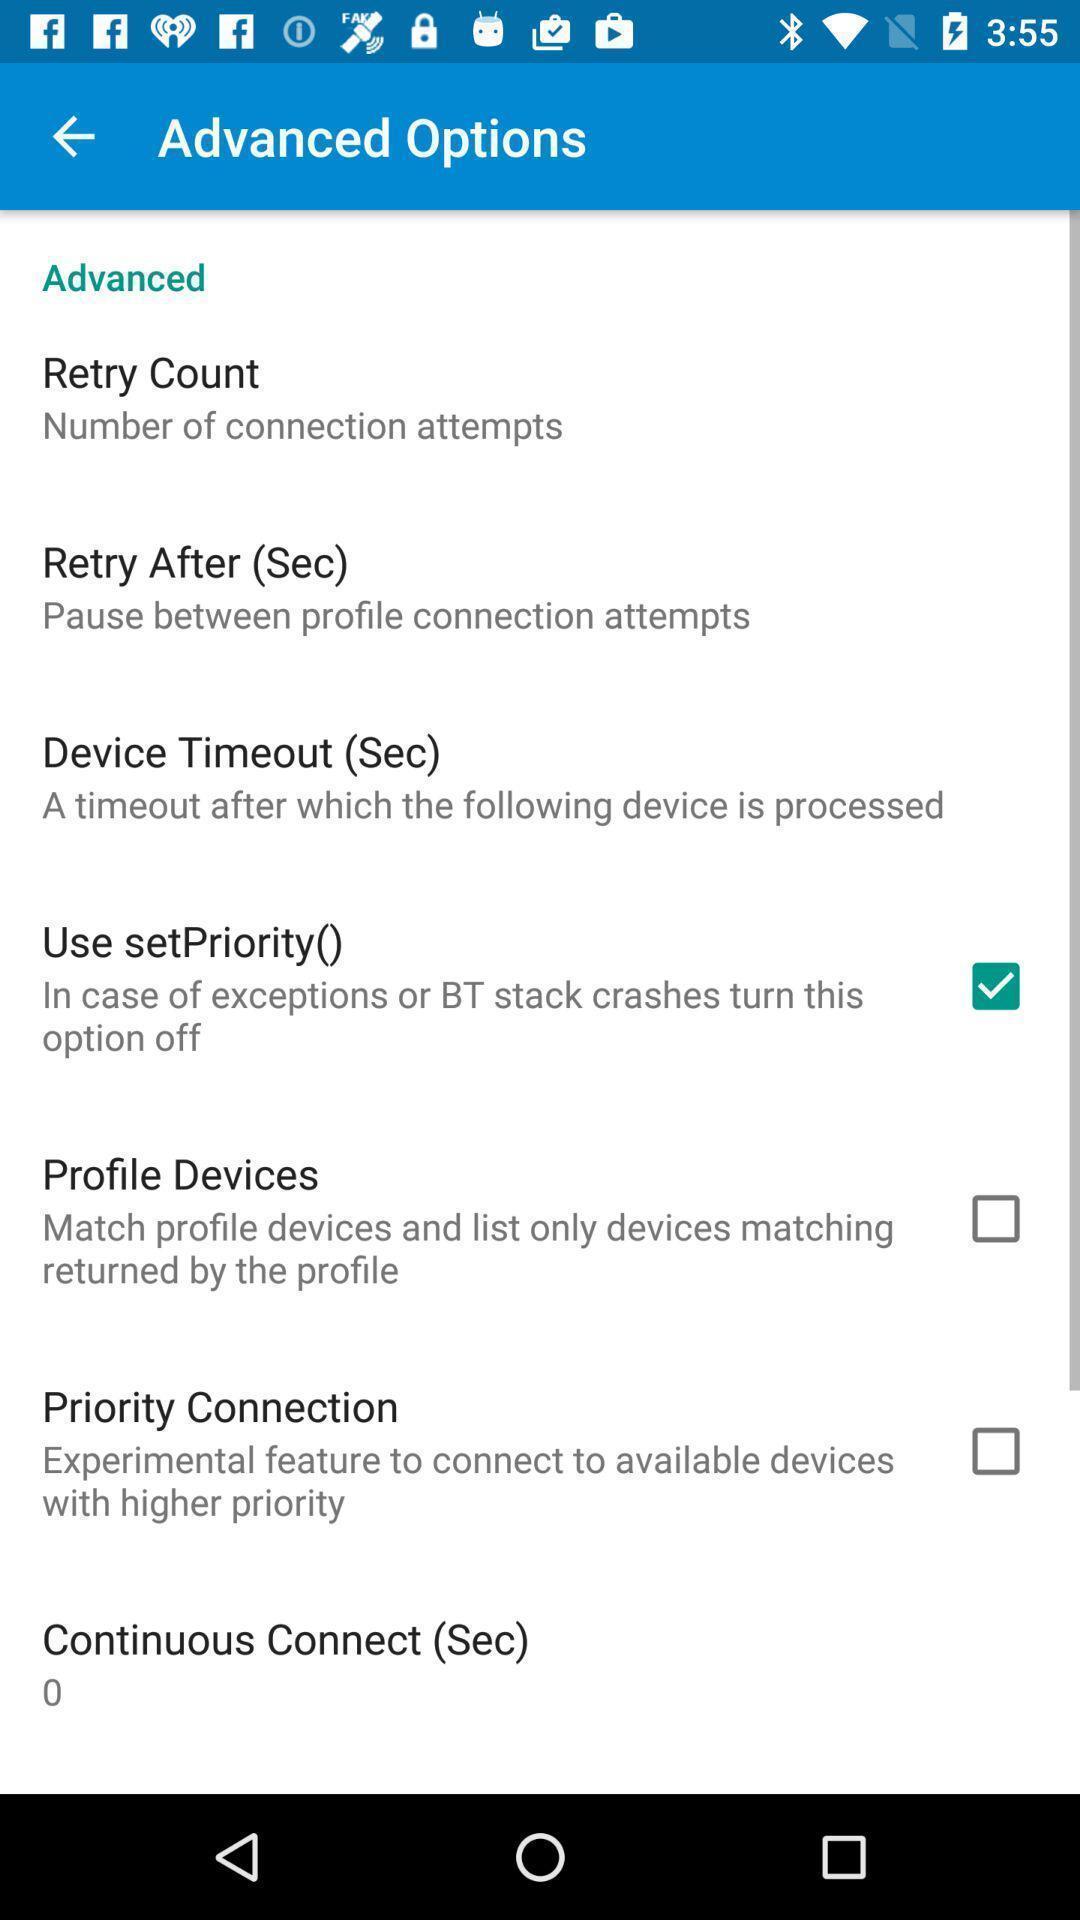What details can you identify in this image? Screen displaying few advanced options on a device. 